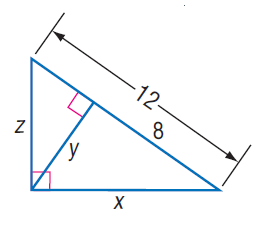Answer the mathemtical geometry problem and directly provide the correct option letter.
Question: Find z.
Choices: A: 2 \sqrt { 3 } B: 4 C: 4 \sqrt { 3 } D: 12 C 